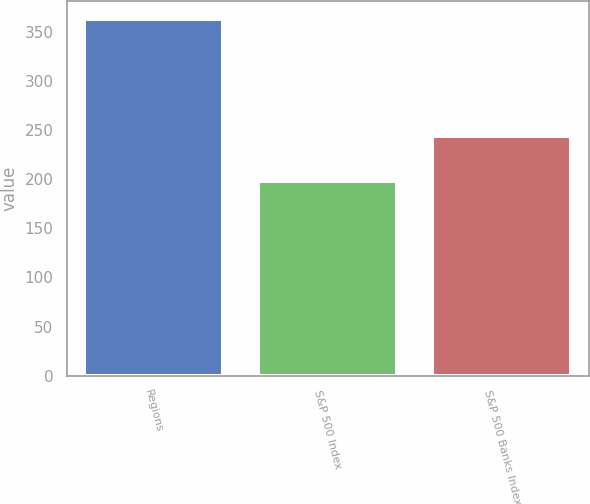<chart> <loc_0><loc_0><loc_500><loc_500><bar_chart><fcel>Regions<fcel>S&P 500 Index<fcel>S&P 500 Banks Index<nl><fcel>362.82<fcel>198.09<fcel>243.82<nl></chart> 